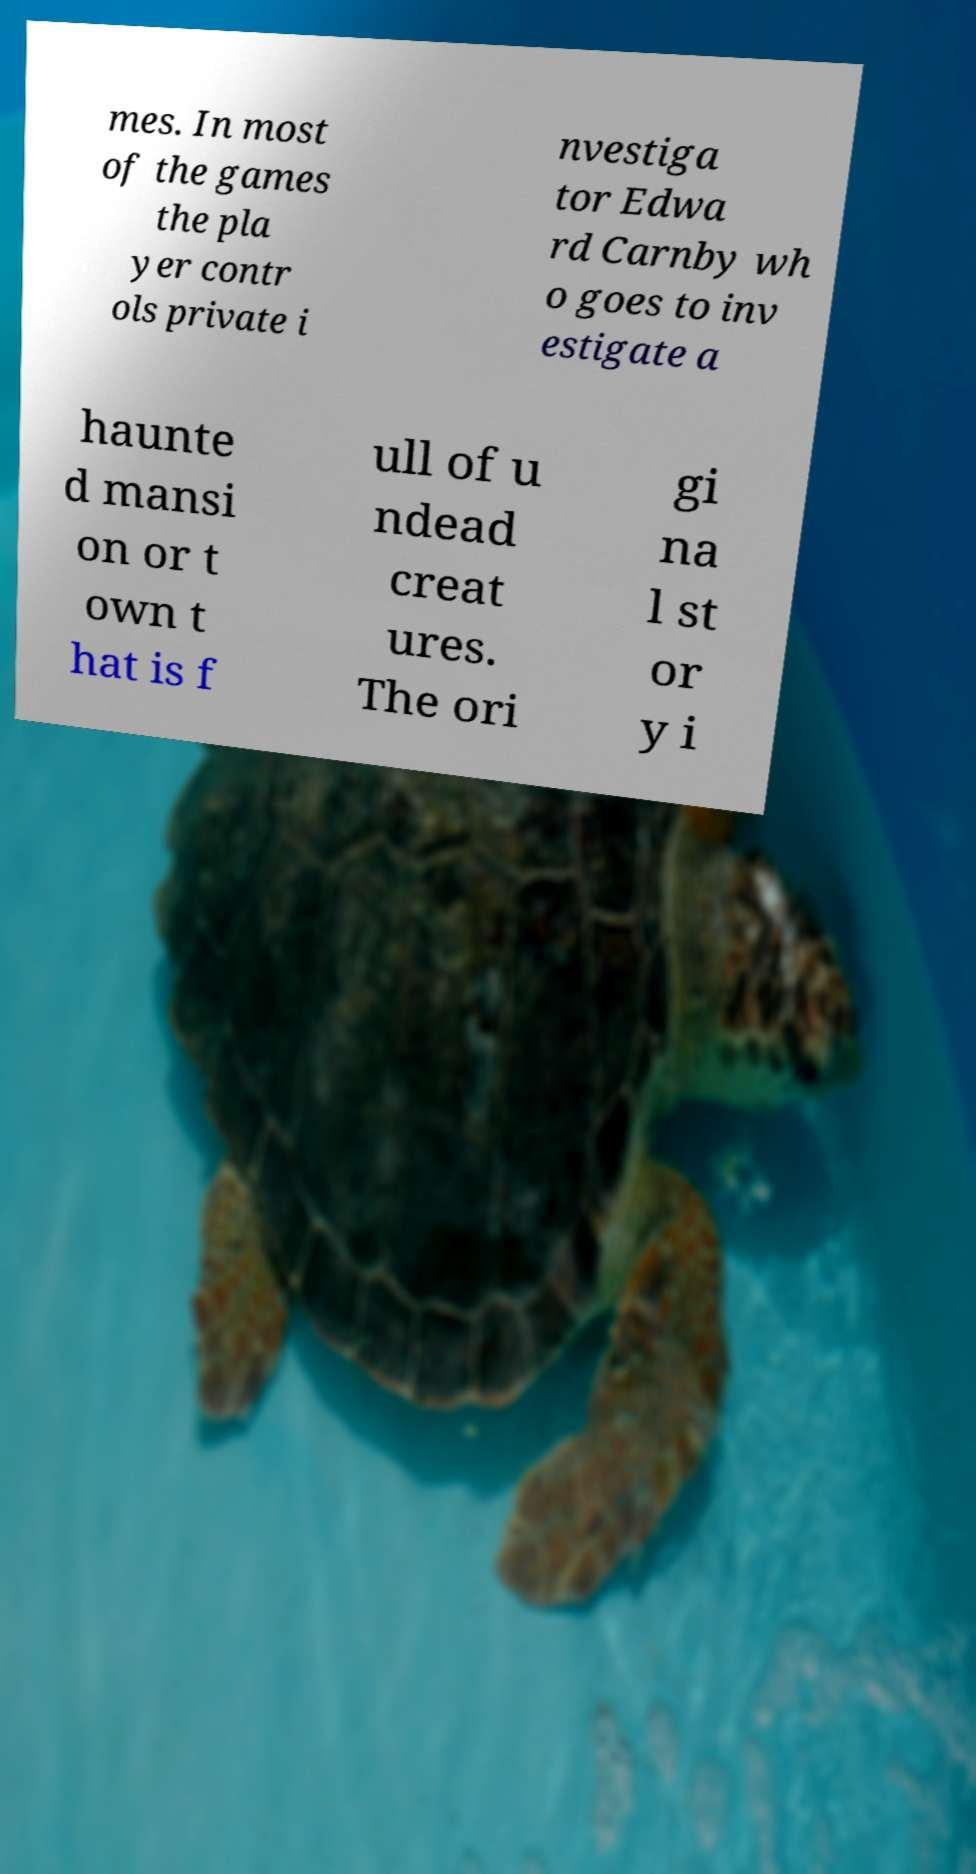Could you assist in decoding the text presented in this image and type it out clearly? mes. In most of the games the pla yer contr ols private i nvestiga tor Edwa rd Carnby wh o goes to inv estigate a haunte d mansi on or t own t hat is f ull of u ndead creat ures. The ori gi na l st or y i 